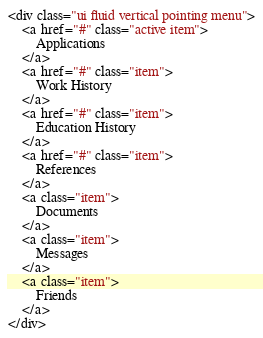<code> <loc_0><loc_0><loc_500><loc_500><_HTML_><div class="ui fluid vertical pointing menu">
    <a href="#" class="active item">
        Applications
    </a>
    <a href="#" class="item">
        Work History
    </a>
    <a href="#" class="item">
        Education History
    </a>
    <a href="#" class="item">
        References
    </a>
    <a class="item">
        Documents
    </a>
    <a class="item">
        Messages
    </a>
    <a class="item">
        Friends
    </a>
</div></code> 